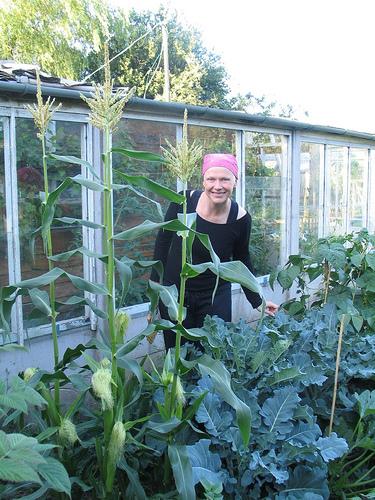Why is the woman wearing a scarf?
Be succinct. To protect her head. What is on her head?
Short answer required. Bandana. Is this a garden?
Concise answer only. Yes. 